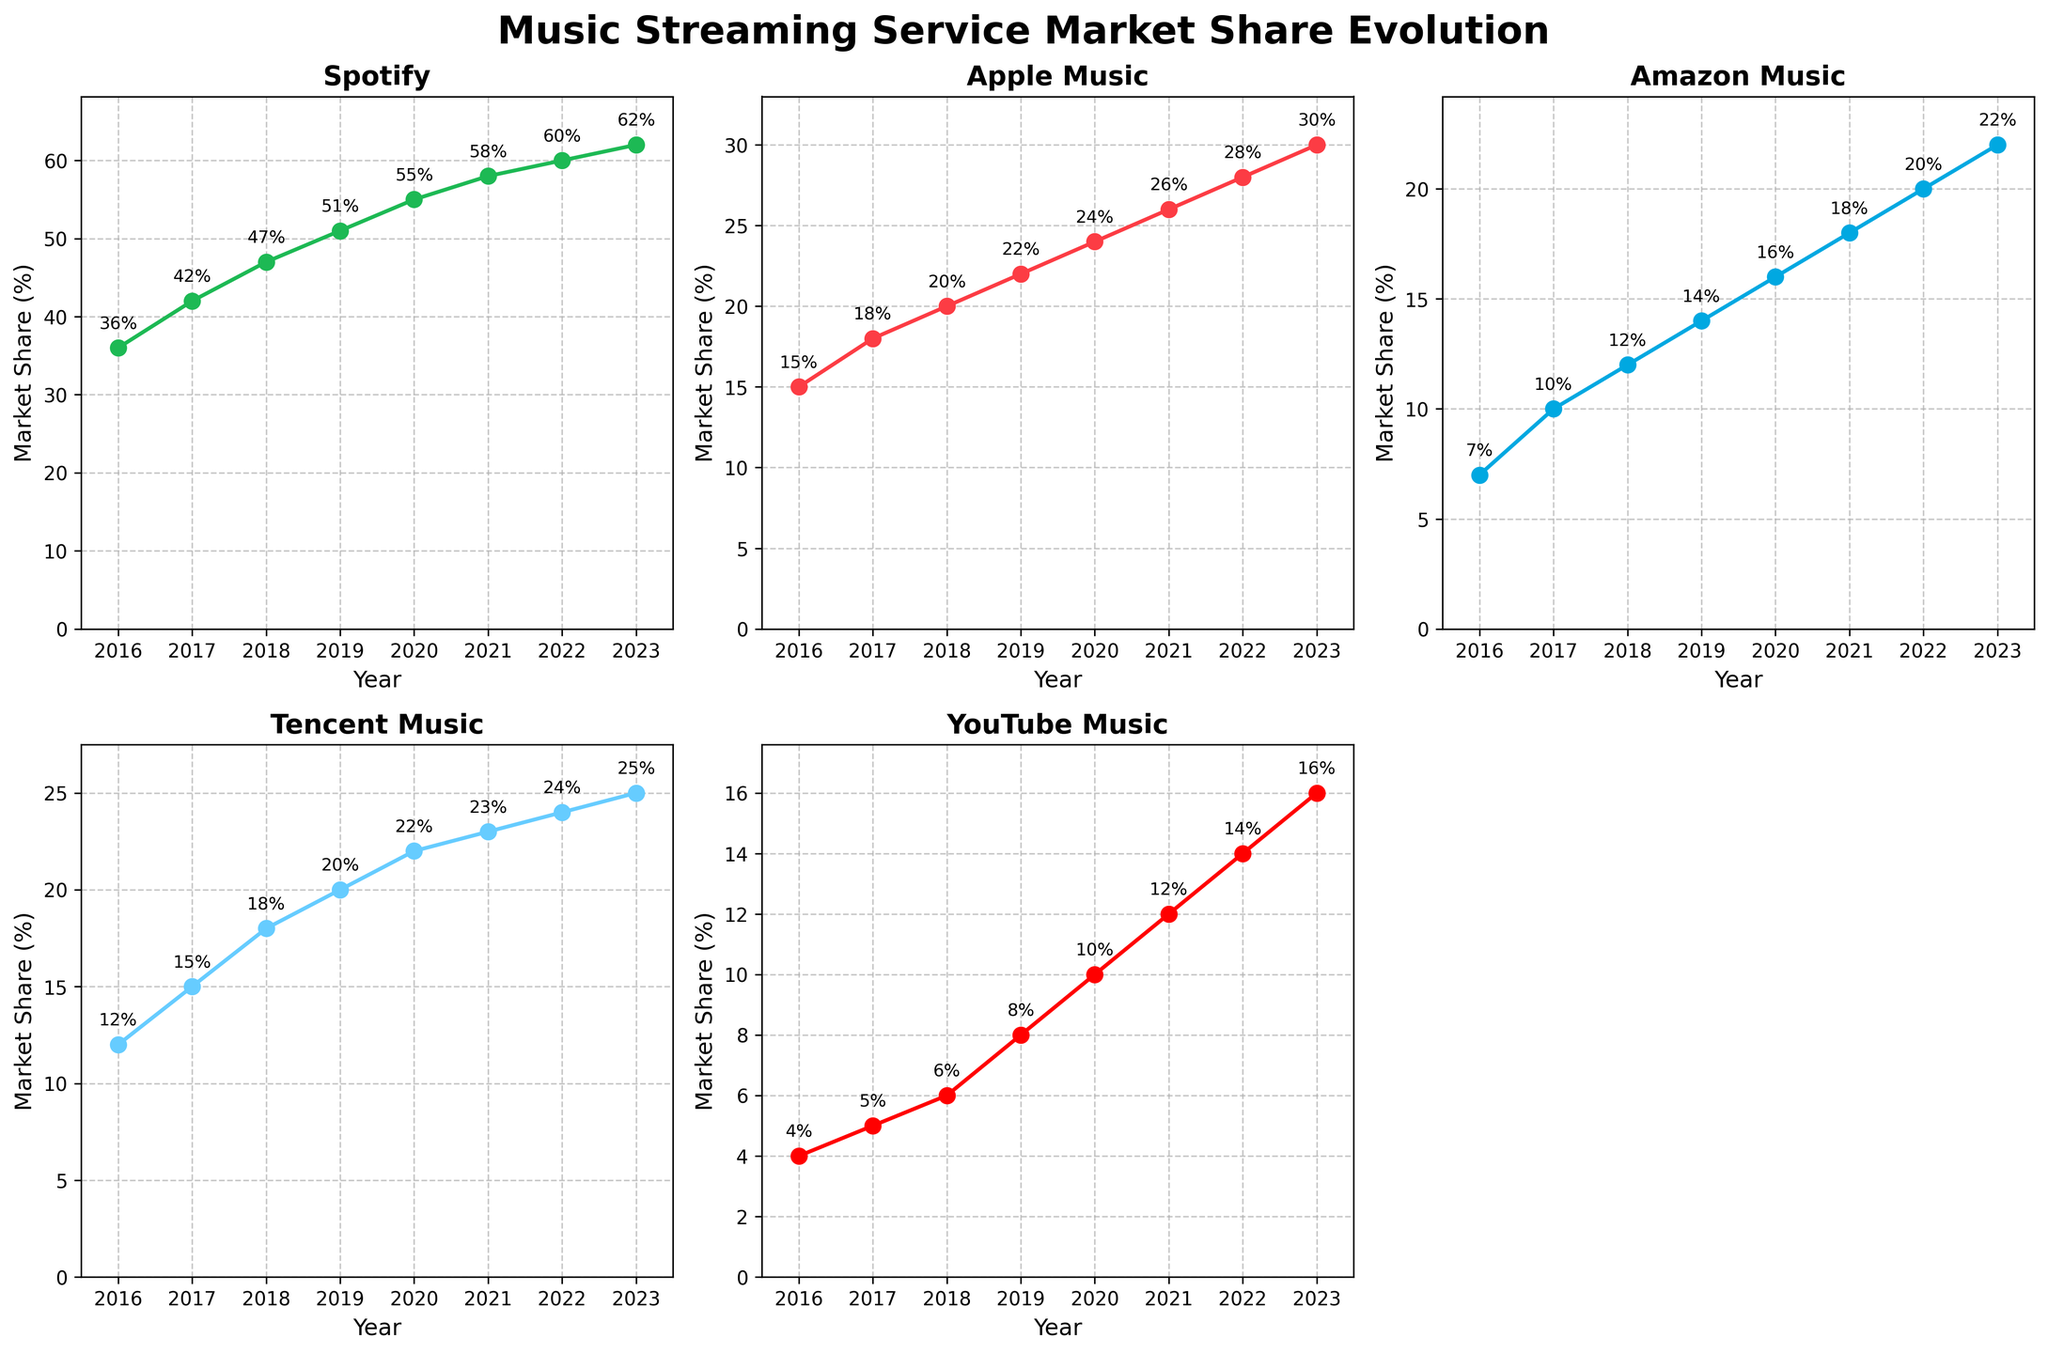How did Spotify's market share change from 2016 to 2023? Observing Spotify's line plot, its market share increased from 36% in 2016 to 62% in 2023.
Answer: 36% to 62% Which music streaming service showed the least growth in market share from 2016 to 2023? By comparing the starting and ending points of the line plots, Tencent Music grew from 12% to 25%, which is the smallest absolute increase among the top five platforms.
Answer: Tencent Music What was the combined market share of Apple Music and YouTube Music in 2020? Apple Music had 24% and YouTube Music had 10% in 2020. Summing these gives a combined market share of 34%.
Answer: 34% Between 2018 and 2022, which streaming service had the highest average market share? Calculating the average of market shares from 2018 to 2022 for each service, Spotify had the highest average, calculated as (47 + 51 + 55 + 58 + 60)/5 = 54.2%.
Answer: Spotify How many percentage points did Amazon Music's market share increase from 2016 to 2023? In 2016, Amazon Music had 7%, and in 2023 it had 22%. The difference is 22% - 7% = 15%.
Answer: 15% Which music streaming service had the highest market share in 2018? From observing the values in 2018, Spotify had the highest market share at 47%.
Answer: Spotify Was there any year where Apple Music's market share was equal to YouTube Music's market share? Observing the plot, there is no year where both Apple Music and YouTube Music have equal market shares.
Answer: No In which year did Tencent Music's market share exceed that of Amazon Music for the first time? Checking both lines, Tencent Music exceeded Amazon Music in 2017 with 15% compared to Amazon Music's 10%.
Answer: 2017 Which color represents YouTube Music in the subplots? The YouTube Music line plot is red, which can be identified by both the title and the color used in that subplot.
Answer: Red 